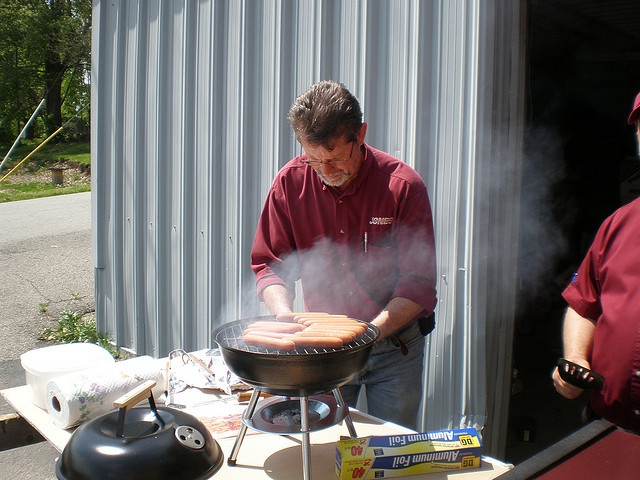Describe the objects in this image and their specific colors. I can see people in darkgreen, maroon, black, gray, and darkgray tones, people in darkgreen, black, maroon, and brown tones, bowl in darkgreen, white, darkgray, and lightblue tones, hot dog in darkgreen, tan, maroon, and brown tones, and hot dog in darkgreen, ivory, gray, and salmon tones in this image. 